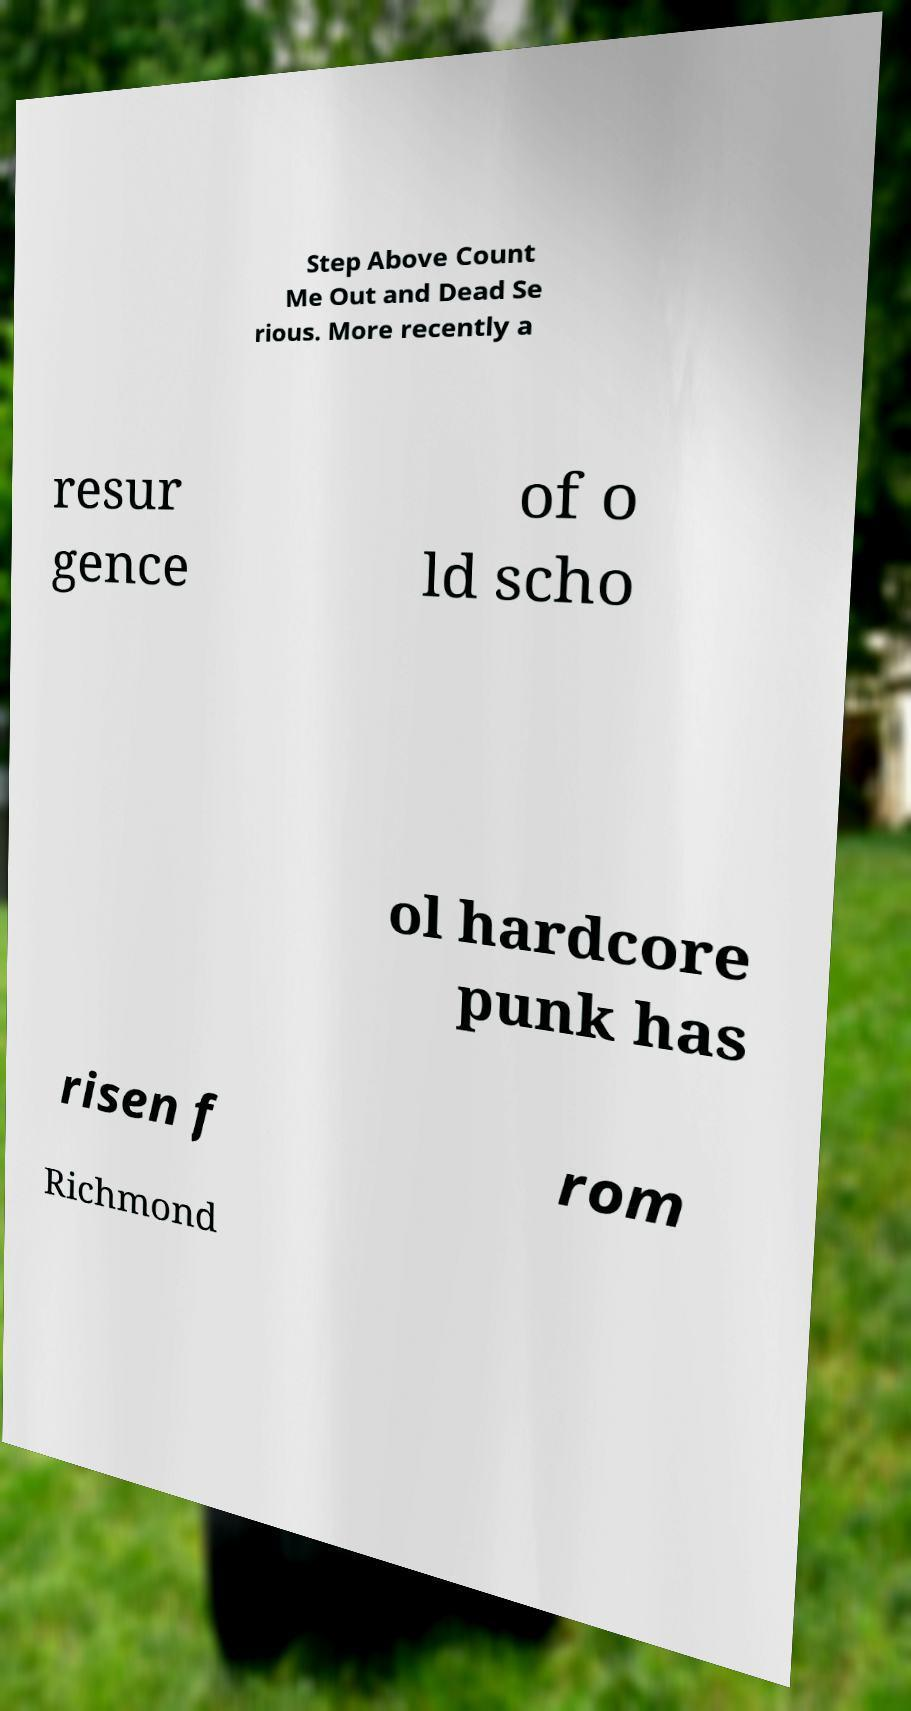There's text embedded in this image that I need extracted. Can you transcribe it verbatim? Step Above Count Me Out and Dead Se rious. More recently a resur gence of o ld scho ol hardcore punk has risen f rom Richmond 